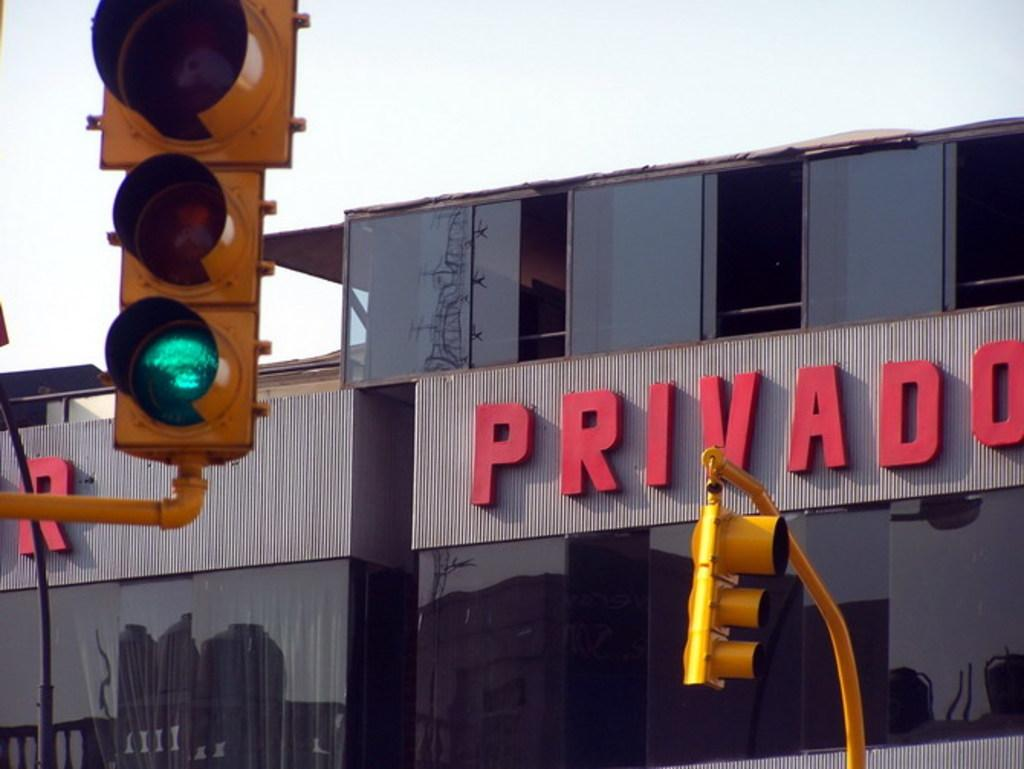<image>
Create a compact narrative representing the image presented. A traffic light with Privado building in the background 